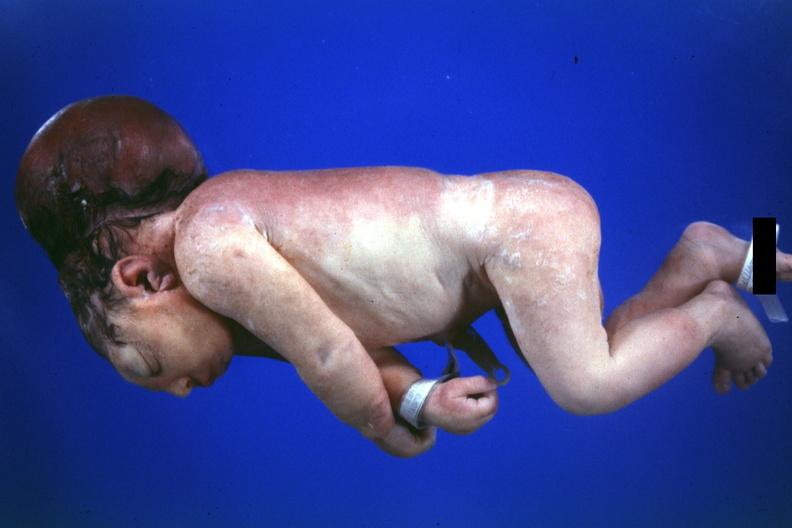s no chromosomal defects lived one day?
Answer the question using a single word or phrase. Yes 